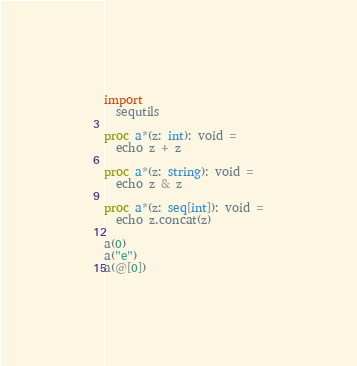<code> <loc_0><loc_0><loc_500><loc_500><_Nim_>import
  sequtils

proc a*(z: int): void =
  echo z + z

proc a*(z: string): void =
  echo z & z

proc a*(z: seq[int]): void =
  echo z.concat(z)

a(0)
a("e")
a(@[0])
</code> 